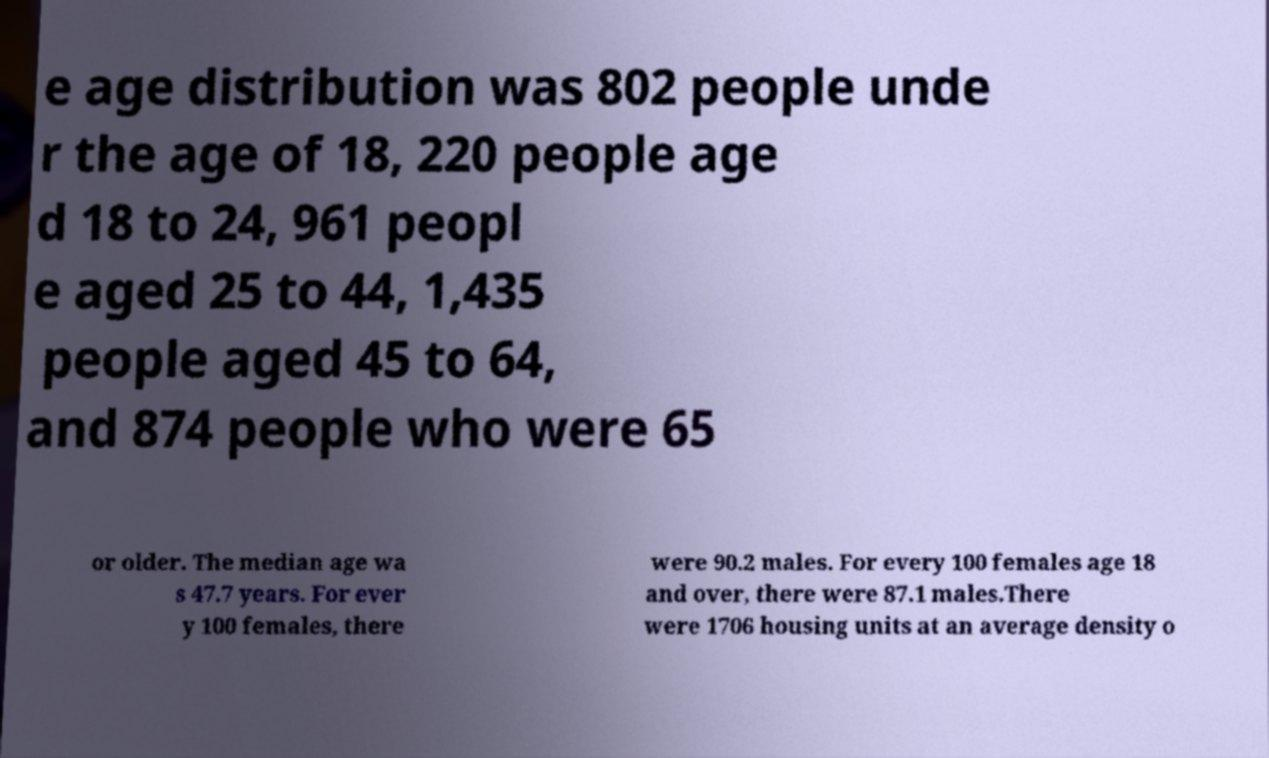Could you extract and type out the text from this image? e age distribution was 802 people unde r the age of 18, 220 people age d 18 to 24, 961 peopl e aged 25 to 44, 1,435 people aged 45 to 64, and 874 people who were 65 or older. The median age wa s 47.7 years. For ever y 100 females, there were 90.2 males. For every 100 females age 18 and over, there were 87.1 males.There were 1706 housing units at an average density o 